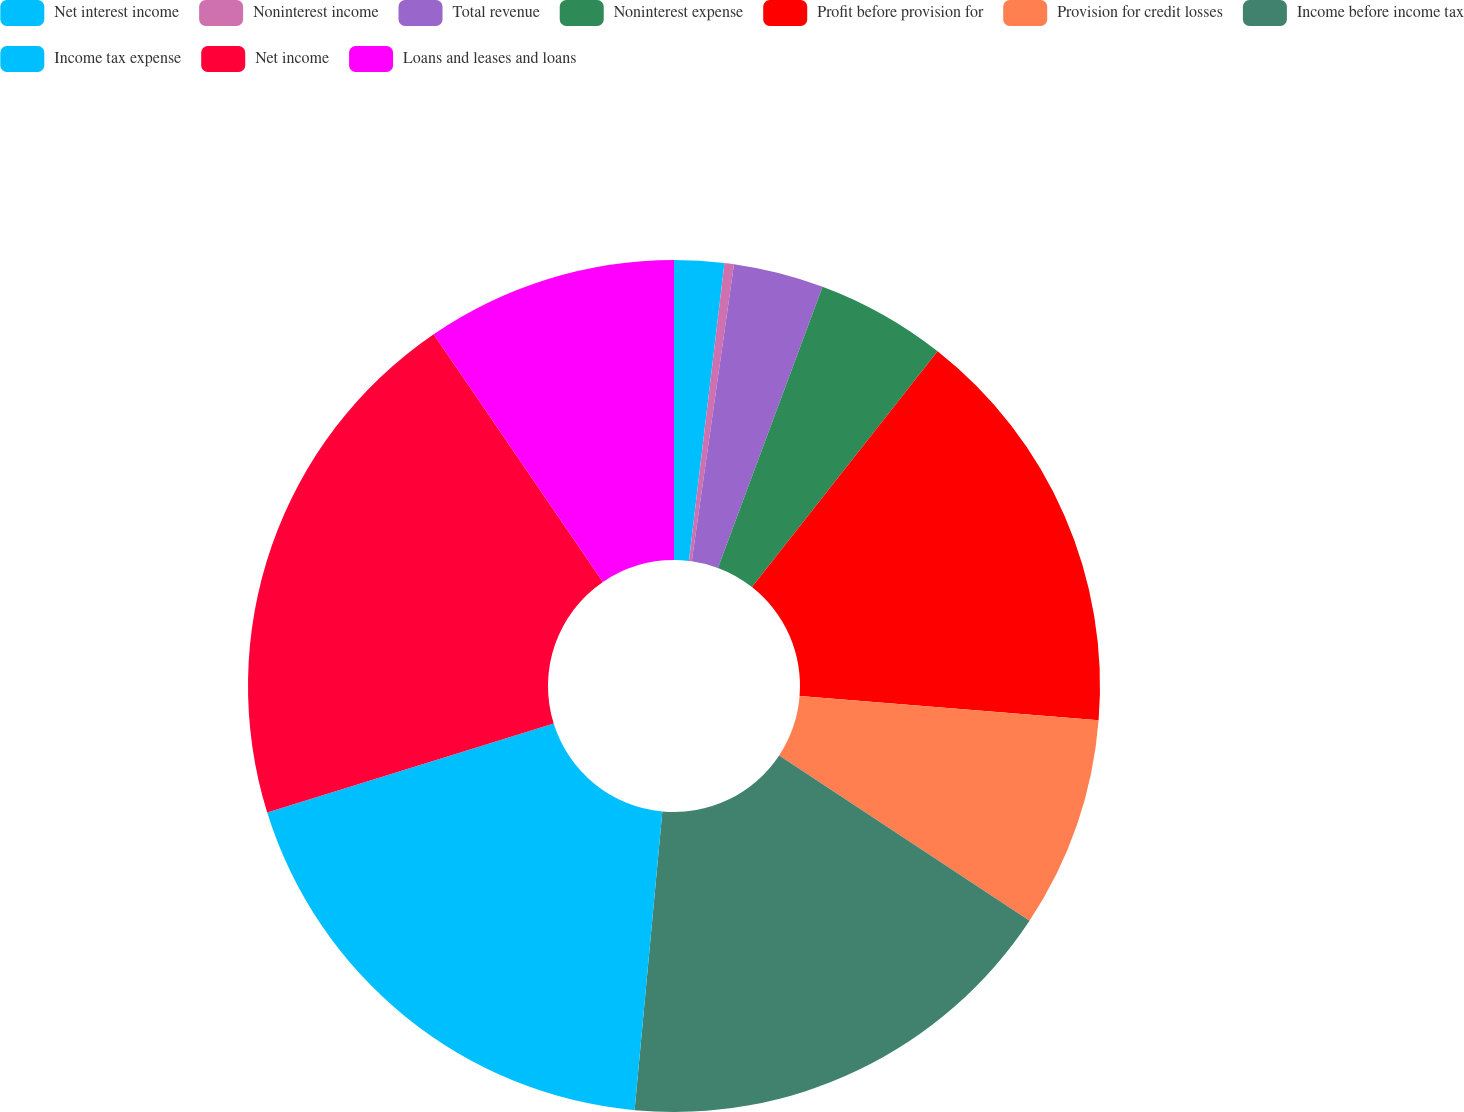Convert chart to OTSL. <chart><loc_0><loc_0><loc_500><loc_500><pie_chart><fcel>Net interest income<fcel>Noninterest income<fcel>Total revenue<fcel>Noninterest expense<fcel>Profit before provision for<fcel>Provision for credit losses<fcel>Income before income tax<fcel>Income tax expense<fcel>Net income<fcel>Loans and leases and loans<nl><fcel>1.89%<fcel>0.36%<fcel>3.42%<fcel>4.95%<fcel>15.66%<fcel>8.01%<fcel>17.19%<fcel>18.73%<fcel>20.26%<fcel>9.54%<nl></chart> 